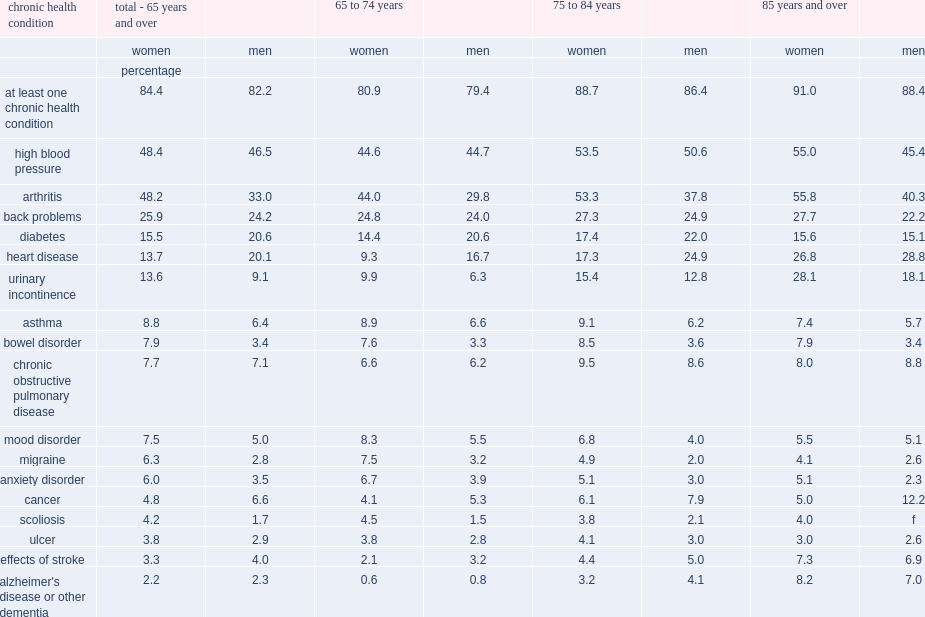What's the percentage of senior women living in private households had at least one chronic health condition. 84.4. What's the percentage of women aged 85 and over had at least one chronic health condition. 91.0. Which is less likely to had at least one chronic health condition,senior men or senior women. Men total - 65 years and over. 